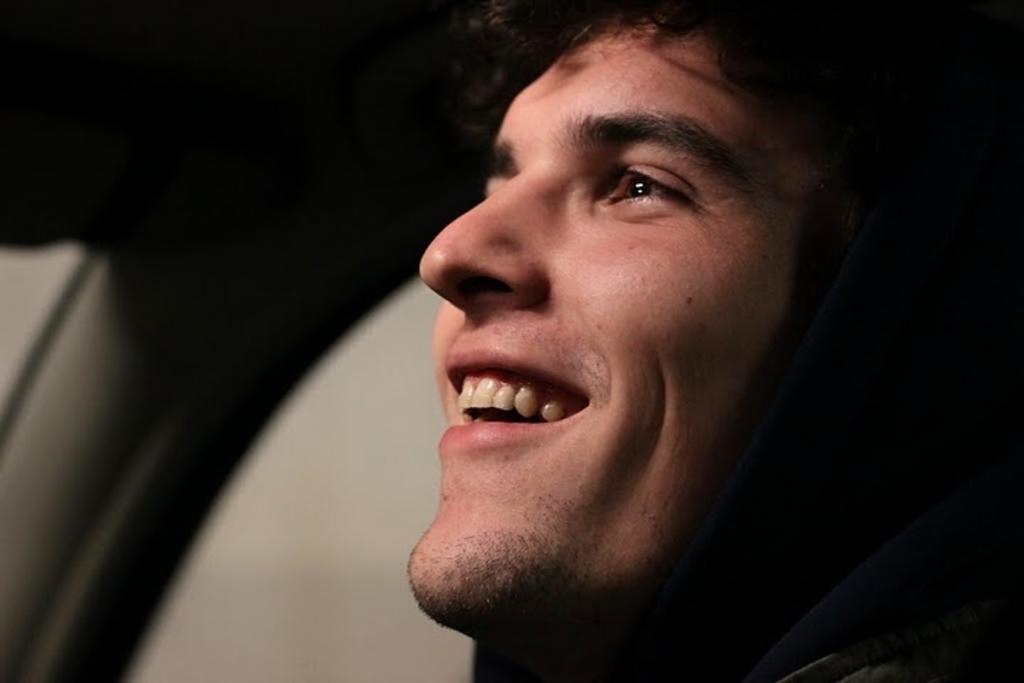Can you describe this image briefly? There is a man smiling. In the background it is dark. 